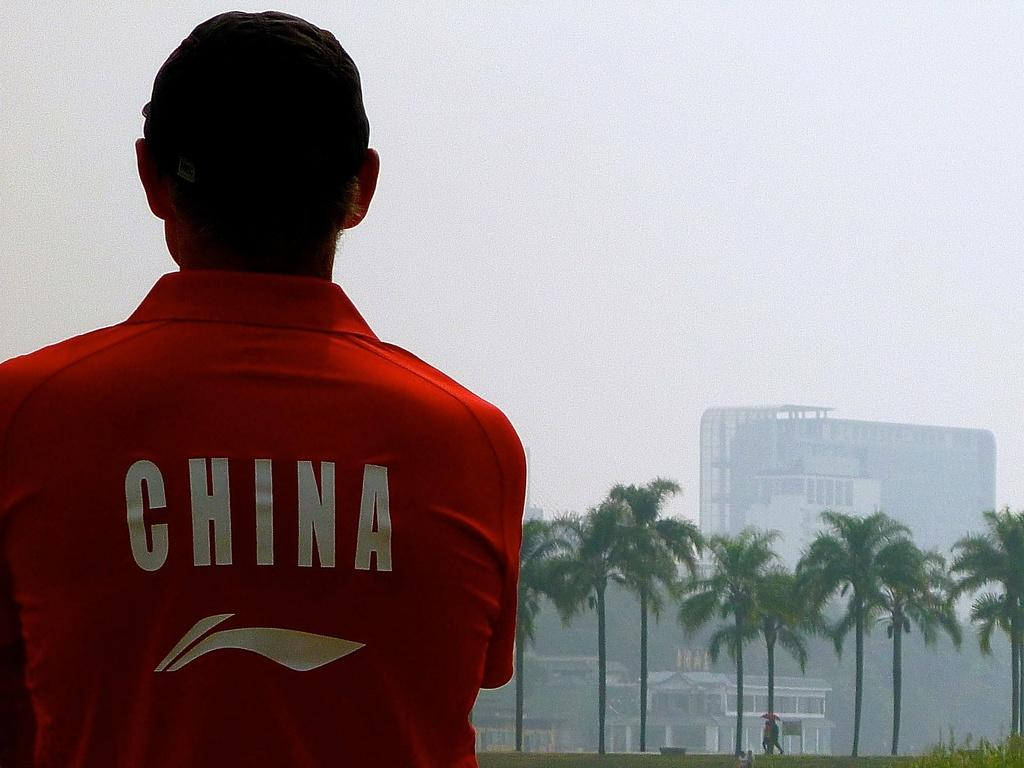<image>
Render a clear and concise summary of the photo. A man in a red shirt with the word China on it in white. 